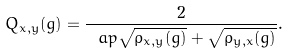Convert formula to latex. <formula><loc_0><loc_0><loc_500><loc_500>Q _ { x , y } ( g ) = \frac { 2 } { \ a p { \sqrt { \varrho _ { x , y } ( g ) } + \sqrt { \varrho _ { y , x } ( g ) } } } .</formula> 